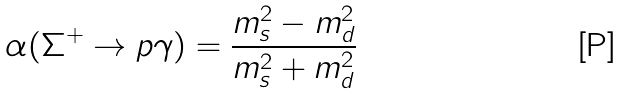Convert formula to latex. <formula><loc_0><loc_0><loc_500><loc_500>\alpha ( \Sigma ^ { + } \rightarrow p \gamma ) = \frac { m ^ { 2 } _ { s } - m ^ { 2 } _ { d } } { m ^ { 2 } _ { s } + m ^ { 2 } _ { d } }</formula> 